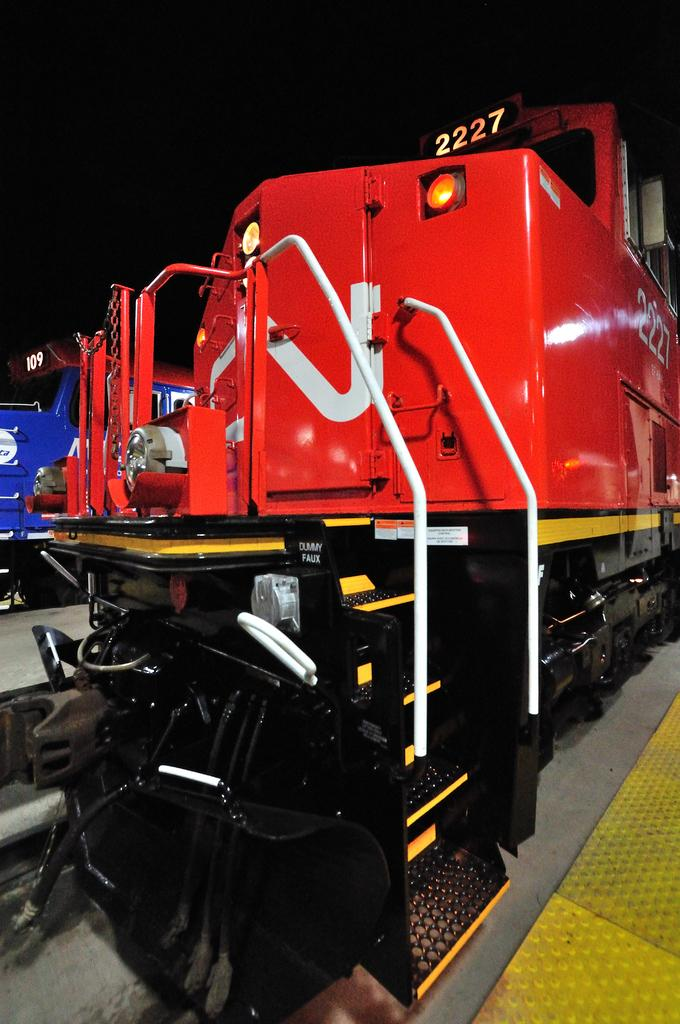What types of trains are present in the image? There is a red train and a blue train in the image. What color is the background of the image? The background of the image is black. What type of building can be seen in the background of the image? There is no building present in the image; the background is black. Is there any quicksand visible in the image? There is no quicksand present in the image; it features only trains and a black background. 